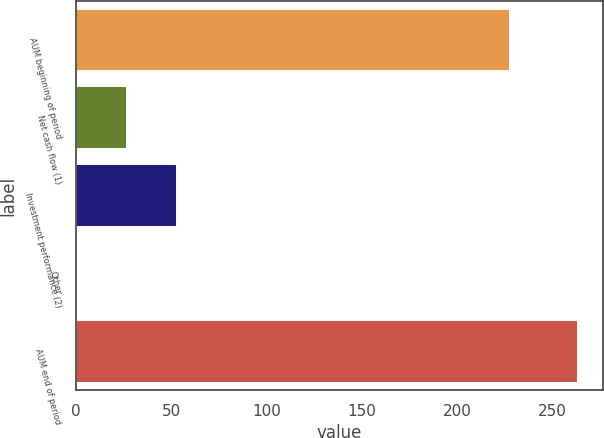<chart> <loc_0><loc_0><loc_500><loc_500><bar_chart><fcel>AUM beginning of period<fcel>Net cash flow (1)<fcel>Investment performance (2)<fcel>Other<fcel>AUM end of period<nl><fcel>227.8<fcel>26.77<fcel>53.04<fcel>0.5<fcel>263.2<nl></chart> 